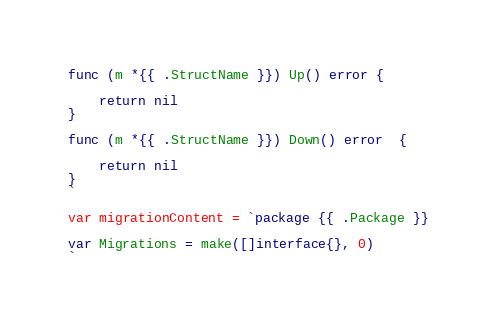<code> <loc_0><loc_0><loc_500><loc_500><_Go_>func (m *{{ .StructName }}) Up() error {

	return nil
}

func (m *{{ .StructName }}) Down() error  {

	return nil
}
`

var migrationContent = `package {{ .Package }}

var Migrations = make([]interface{}, 0)
`
</code> 